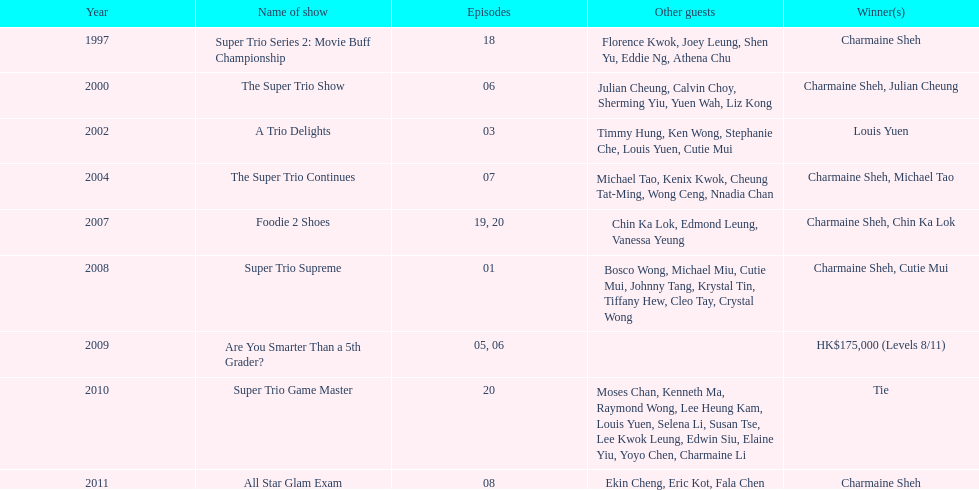What is the count of additional attendees in the 2002 show "a trio delights"? 5. 